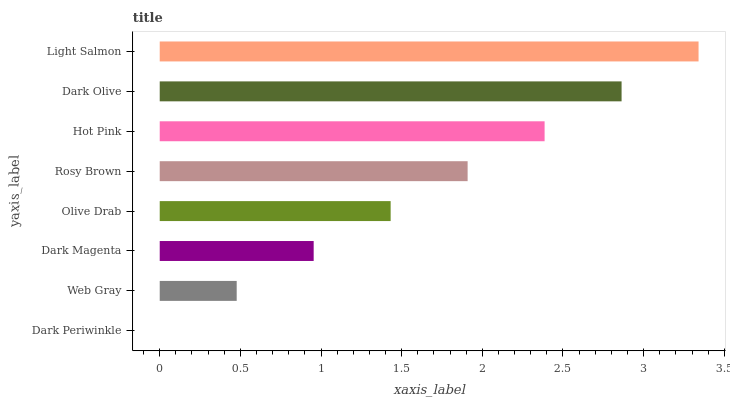Is Dark Periwinkle the minimum?
Answer yes or no. Yes. Is Light Salmon the maximum?
Answer yes or no. Yes. Is Web Gray the minimum?
Answer yes or no. No. Is Web Gray the maximum?
Answer yes or no. No. Is Web Gray greater than Dark Periwinkle?
Answer yes or no. Yes. Is Dark Periwinkle less than Web Gray?
Answer yes or no. Yes. Is Dark Periwinkle greater than Web Gray?
Answer yes or no. No. Is Web Gray less than Dark Periwinkle?
Answer yes or no. No. Is Rosy Brown the high median?
Answer yes or no. Yes. Is Olive Drab the low median?
Answer yes or no. Yes. Is Dark Olive the high median?
Answer yes or no. No. Is Web Gray the low median?
Answer yes or no. No. 